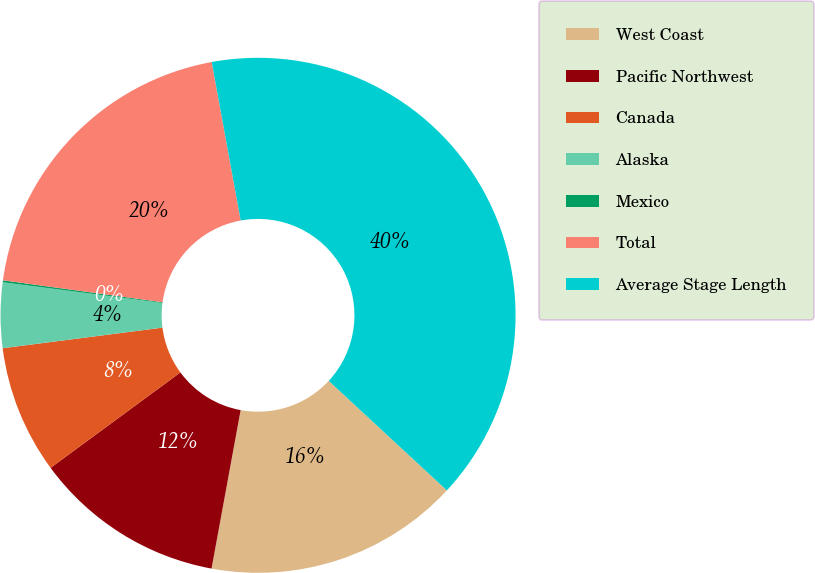<chart> <loc_0><loc_0><loc_500><loc_500><pie_chart><fcel>West Coast<fcel>Pacific Northwest<fcel>Canada<fcel>Alaska<fcel>Mexico<fcel>Total<fcel>Average Stage Length<nl><fcel>15.99%<fcel>12.02%<fcel>8.05%<fcel>4.09%<fcel>0.12%<fcel>19.95%<fcel>39.78%<nl></chart> 